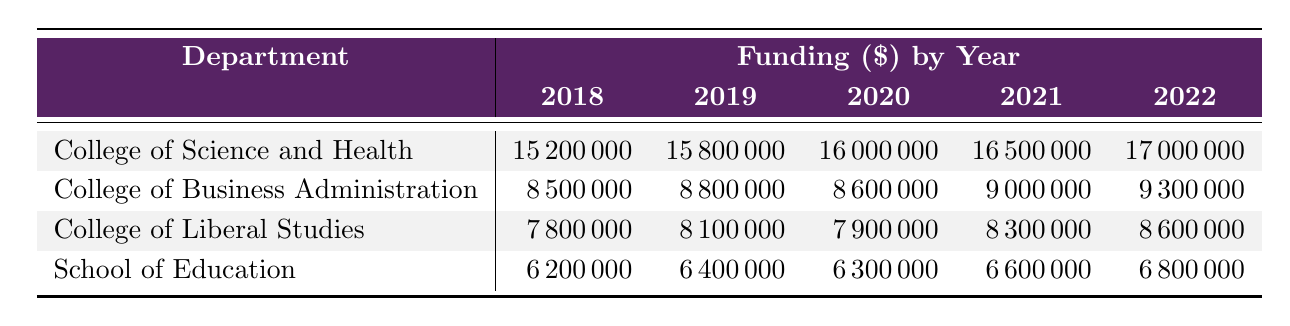What was the funding amount for the College of Science and Health in 2021? The table shows that the funding amount for the College of Science and Health in 2021 is 16500000.
Answer: 16500000 What department received the least amount of funding in 2018? Looking at the funding amounts for 2018, the School of Education received the least amount with 6200000.
Answer: School of Education What was the total funding for the College of Business Administration over the 5 years? The sum of the funding for the College of Business Administration from 2018 to 2022 is: 8500000 + 8800000 + 8600000 + 9000000 + 9300000 = 43200000.
Answer: 43200000 Did the funding for the College of Liberal Studies increase every year from 2018 to 2022? The funding for the College of Liberal Studies was 7800000 in 2018, 8100000 in 2019, 7900000 in 2020, 8300000 in 2021, and 8600000 in 2022. The funding decreased in 2020 compared to 2019, so it did not increase every year.
Answer: No Which department had the highest total funding across all years? To determine the highest total funding, we calculate the total funding for each department: College of Science and Health: 15200000 + 15800000 + 16000000 + 16500000 + 17000000 = 80500000; College of Business Administration: 8500000 + 8800000 + 8600000 + 9000000 + 9300000 = 43200000; College of Liberal Studies: 7800000 + 8100000 + 7900000 + 8300000 + 8600000 = 40600000; School of Education: 6200000 + 6400000 + 6300000 + 6600000 + 6800000 = 33300000. The College of Science and Health has the highest total funding of 80500000.
Answer: College of Science and Health What was the average funding for the School of Education over the 5 years? The total funding for the School of Education is 6200000 + 6400000 + 6300000 + 6600000 + 6800000 = 33300000. Dividing this by the number of years (5), the average funding is 33300000 / 5 = 6660000.
Answer: 6660000 